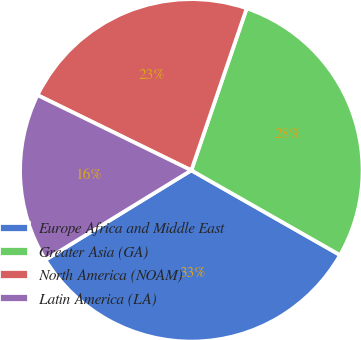<chart> <loc_0><loc_0><loc_500><loc_500><pie_chart><fcel>Europe Africa and Middle East<fcel>Greater Asia (GA)<fcel>North America (NOAM)<fcel>Latin America (LA)<nl><fcel>33.0%<fcel>28.0%<fcel>23.0%<fcel>16.0%<nl></chart> 